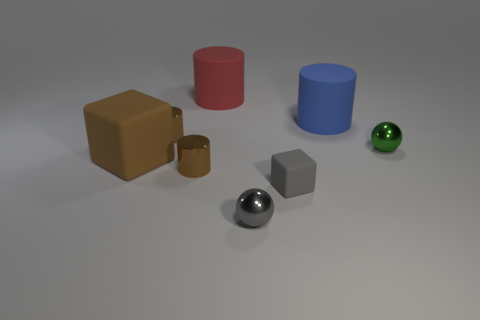What can the presence of multiple shapes and colors in the image signify? The assortment of shapes and colors could suggest a conceptual representation of diversity or variability, a study in geometry and spatial relationships, or perhaps serve an aesthetic purpose to showcase contrast and visual balance. 